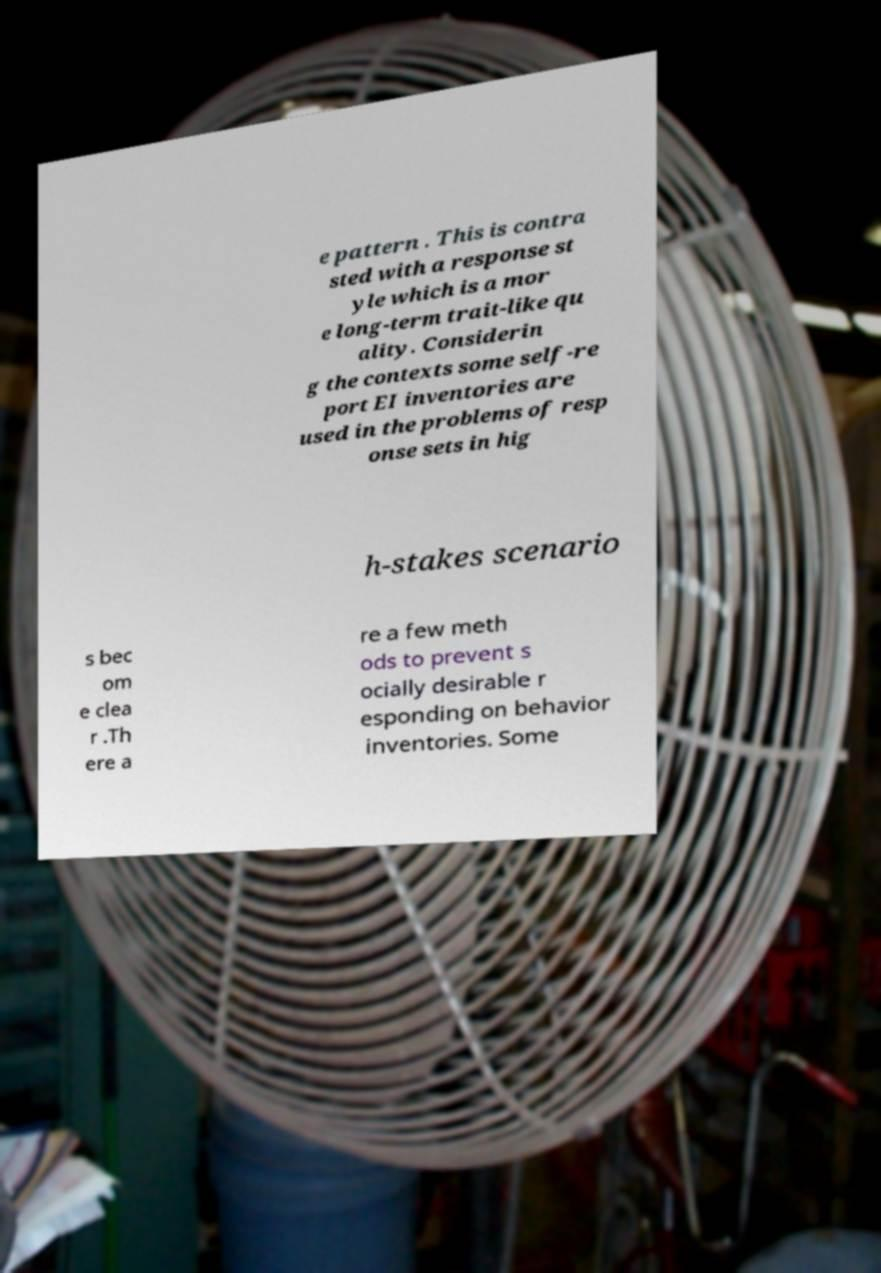Can you accurately transcribe the text from the provided image for me? e pattern . This is contra sted with a response st yle which is a mor e long-term trait-like qu ality. Considerin g the contexts some self-re port EI inventories are used in the problems of resp onse sets in hig h-stakes scenario s bec om e clea r .Th ere a re a few meth ods to prevent s ocially desirable r esponding on behavior inventories. Some 